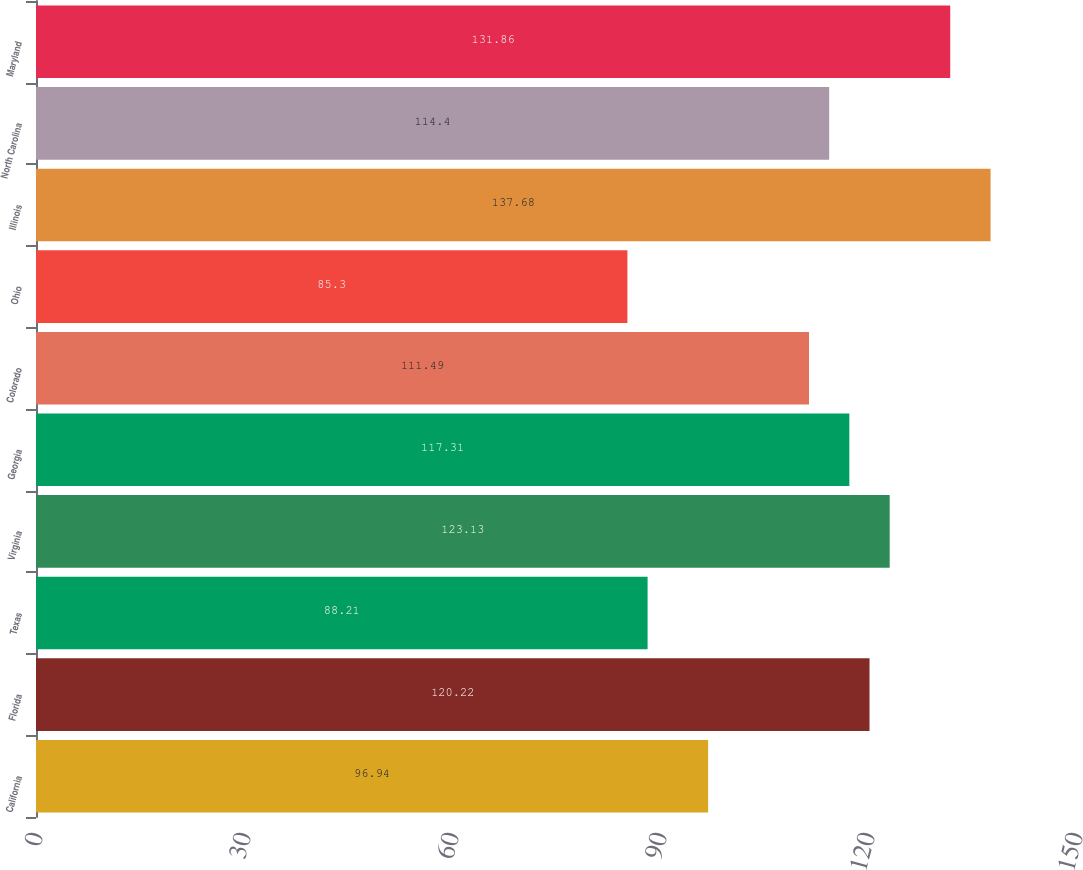Convert chart. <chart><loc_0><loc_0><loc_500><loc_500><bar_chart><fcel>California<fcel>Florida<fcel>Texas<fcel>Virginia<fcel>Georgia<fcel>Colorado<fcel>Ohio<fcel>Illinois<fcel>North Carolina<fcel>Maryland<nl><fcel>96.94<fcel>120.22<fcel>88.21<fcel>123.13<fcel>117.31<fcel>111.49<fcel>85.3<fcel>137.68<fcel>114.4<fcel>131.86<nl></chart> 